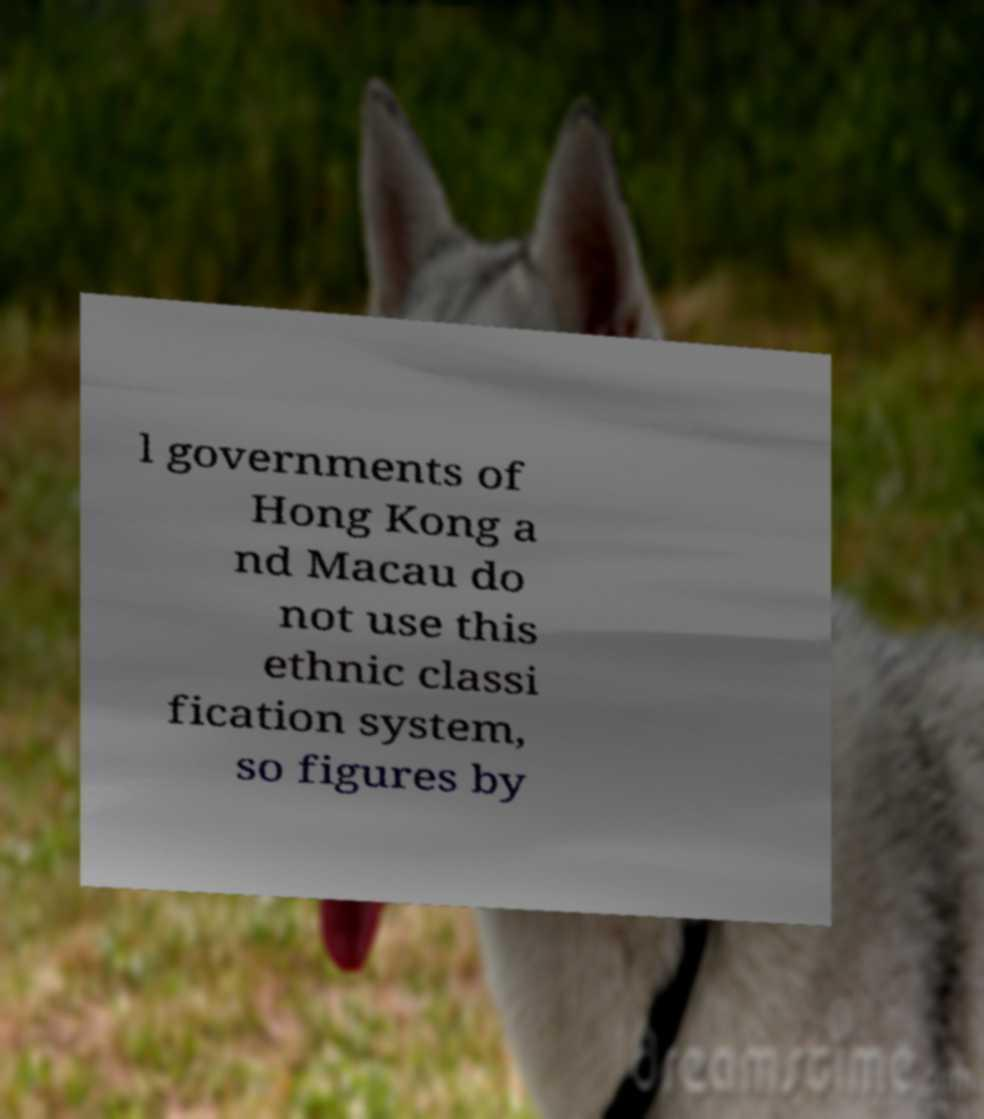Could you assist in decoding the text presented in this image and type it out clearly? l governments of Hong Kong a nd Macau do not use this ethnic classi fication system, so figures by 